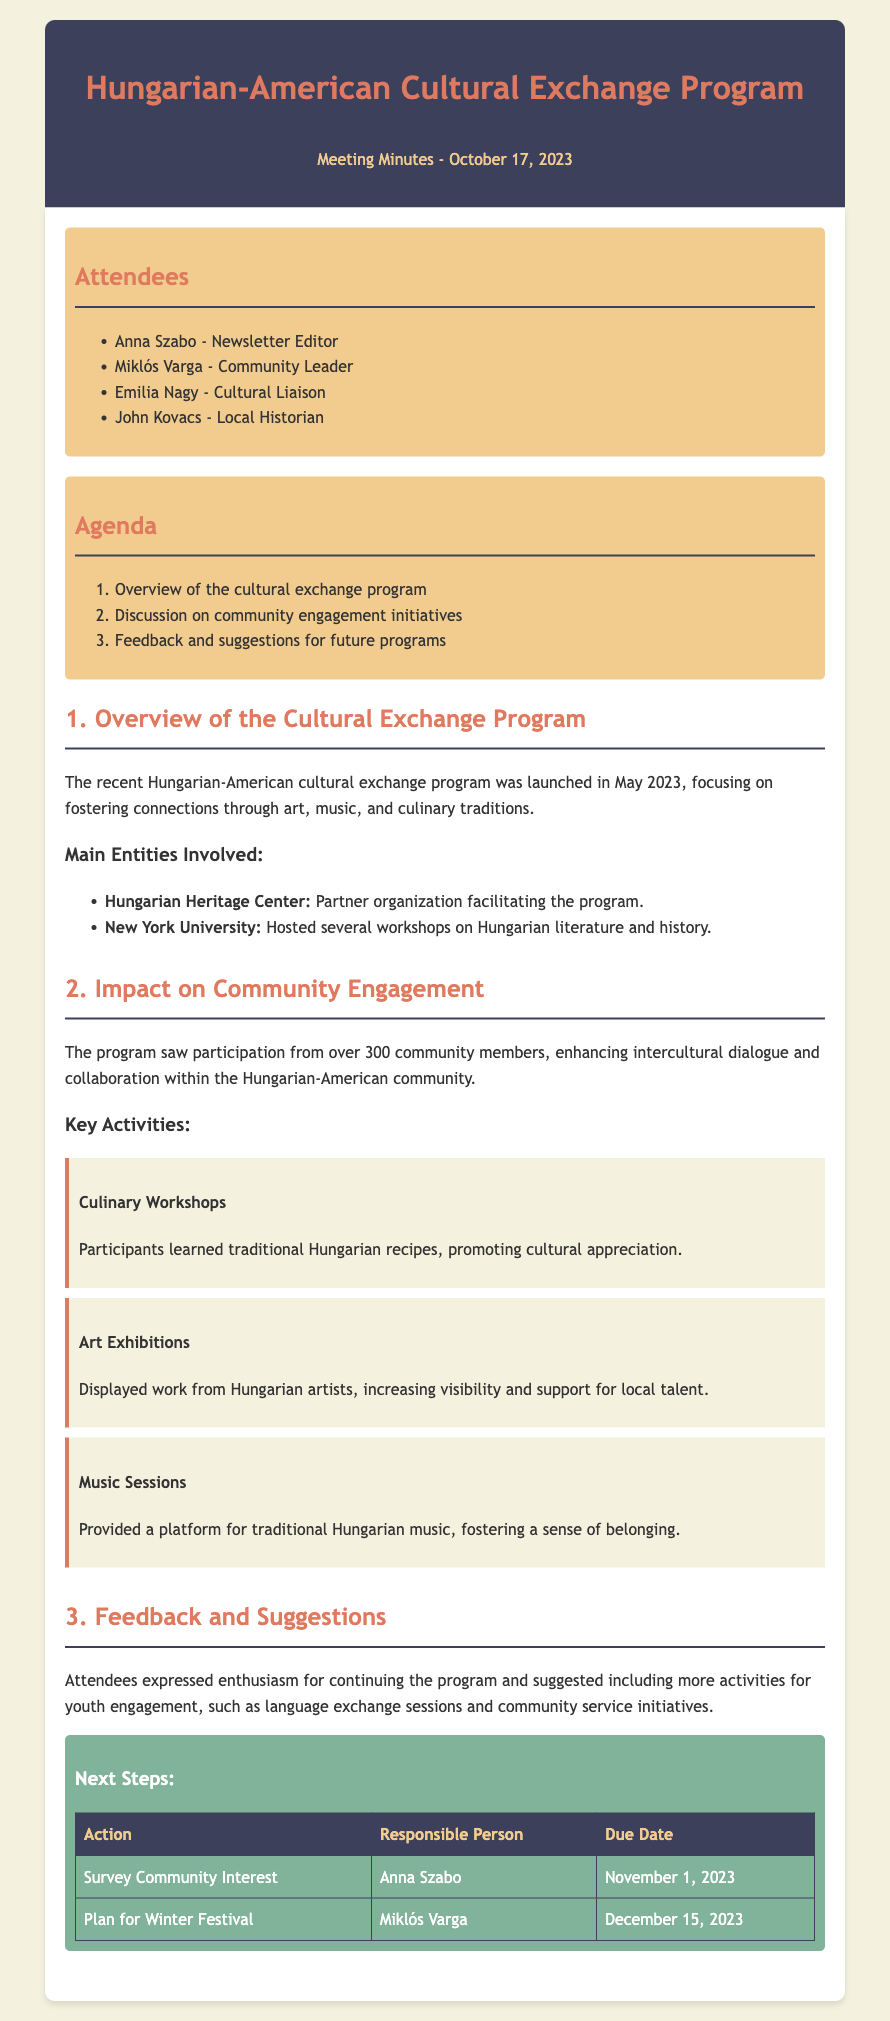what was the launch month of the cultural exchange program? The document states that the cultural exchange program was launched in May 2023.
Answer: May 2023 how many community members participated in the program? The document mentions that over 300 community members participated in the program.
Answer: over 300 who was the community leader present at the meeting? The minutes list Miklós Varga as the community leader who attended the meeting.
Answer: Miklós Varga what key activity focused on culinary traditions? The minutes specify that culinary workshops were one of the key activities of the program.
Answer: Culinary Workshops which organization facilitated the cultural exchange program? The Hungarian Heritage Center is noted as the partner organization facilitating the program.
Answer: Hungarian Heritage Center what feedback was suggested for future activities? Attendees suggested including more activities for youth engagement as feedback for future programs.
Answer: more activities for youth engagement who is responsible for surveying community interest? The action of surveying community interest is assigned to Anna Szabo as per the next steps noted in the document.
Answer: Anna Szabo by when is the plan for the Winter Festival due? The document states that the plan for the Winter Festival is due by December 15, 2023.
Answer: December 15, 2023 what type of document is this? This is a meeting minutes document that details discussions and actions regarding a cultural exchange program.
Answer: meeting minutes 